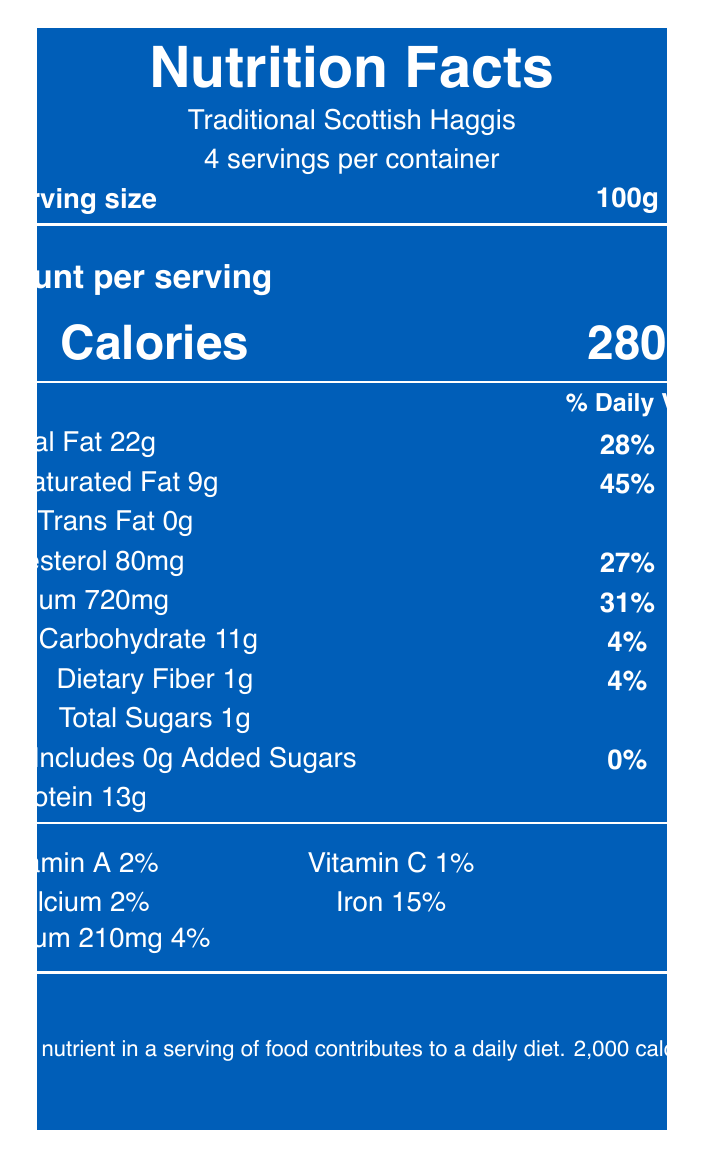what is the serving size of traditional Scottish Haggis? The serving size is listed directly on the document as 100 grams.
Answer: 100 grams how many servings are in a container of traditional Scottish Haggis? The document states that there are 4 servings per container.
Answer: 4 servings how many calories are there per serving? The amount per serving section lists the calorie count as 280.
Answer: 280 calories what is the percentage of daily value for sodium per serving? The document shows that sodium contributes 31% of the daily value per serving.
Answer: 31% what is the total fat content per serving and its daily value percentage? The total fat content is listed as 22 grams, which is 28% of the daily value.
Answer: 22g, 28% which nutrient has the highest daily value percentage per serving? A. Total Fat B. Cholesterol C. Saturated Fat D. Sodium Saturated Fat has the highest daily value percentage at 45%.
Answer: C. Saturated Fat what is the amount of dietary fiber in grams per serving? The dietary fiber content per serving is listed as 1 gram.
Answer: 1 gram are there any added sugars in traditional Scottish Haggis? The document lists that there are 0 grams of added sugars.
Answer: No how much protein is there in one serving? The protein content per serving is 13 grams.
Answer: 13 grams which vitamin has the highest daily value percentage? A. Vitamin A B. Vitamin C C. Calcium D. Iron Iron has the highest daily value percentage at 15%.
Answer: D. Iron is the serving size applicable to all nutritional values provided? All nutritional values in the document are based on the serving size of 100 grams.
Answer: Yes summarize the primary nutritional concerns mentioned in the document. The document highlights the high sodium and fat content as key nutritional concerns, reflecting traditional culinary practices. These values might influence health-conscious individuals and public health policy discussions in Scotland.
Answer: The high sodium content of 720mg per serving, which is 31% of the daily value, is a major concern. Traditional haggis also has a high total fat content, particularly saturated fat, which is 45% of the daily value per serving. These factors are important given modern dietary guidelines and public health discussions. how much potassium is in one serving of traditional Scottish Haggis? The potassium content per serving is 210 milligrams.
Answer: 210mg which of the following ingredients included in traditional Scottish Haggis contains gluten? A. Sheep's heart B. Oatmeal C. Beef suet D. Black pepper The document lists oatmeal, which contains gluten, under allergens.
Answer: B. Oatmeal what is the total cholesterol content per serving? The cholesterol content per serving is listed as 80 milligrams.
Answer: 80mg is the total carbohydrate content per serving more than 10 grams? The total carbohydrate content per serving is 11 grams, which is more than 10 grams.
Answer: Yes is traditional Scottish Haggis suitable for those avoiding trans fats? The document indicates that traditional Scottish Haggis contains 0 grams of trans fat.
Answer: Yes does the document provide information about the origin of the Haggis brand? The document does not specify the brand origin information.
Answer: No how does the document describe the traditional serving context of Haggis in Scottish politics? The additional information section notes that Haggis is traditionally served at Burns Night suppers, which are events often attended by Scottish MPs and political figures.
Answer: It is served at Burns Night suppers, often attended by Scottish MPs and political figures. what percentage of daily value does calcium represent per serving? Calcium represents 2% of the daily value per serving.
Answer: 2% 